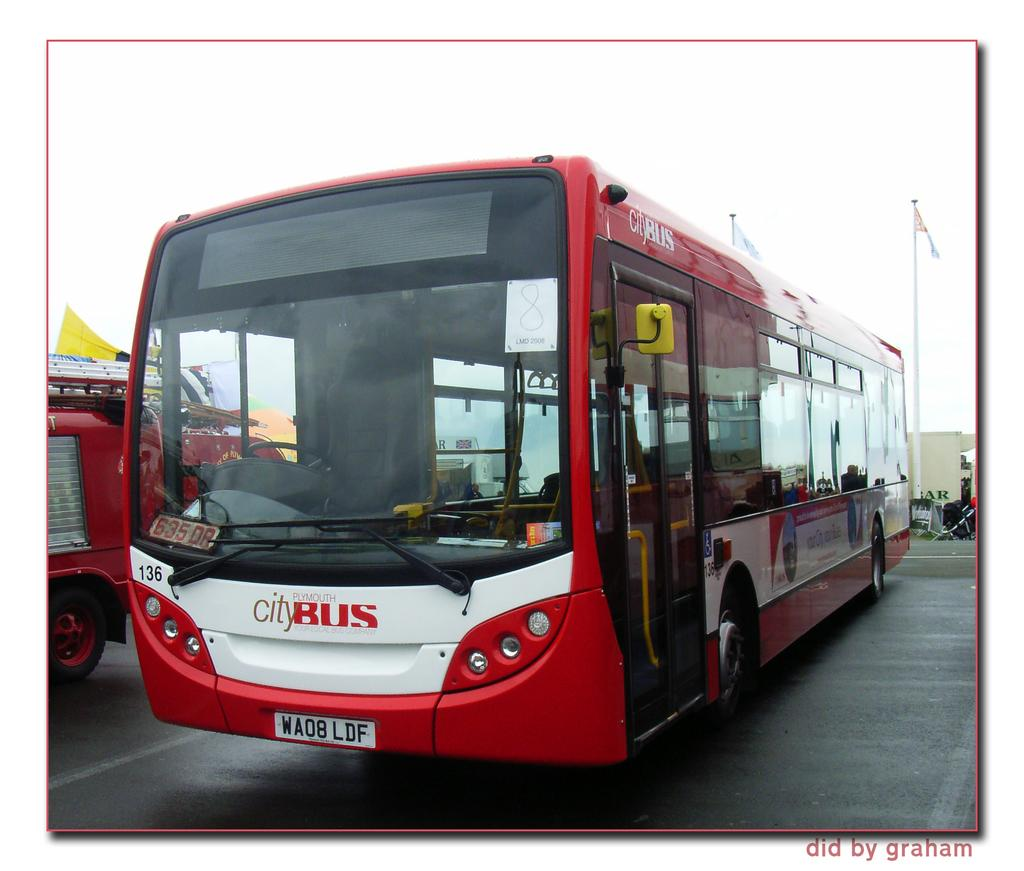Provide a one-sentence caption for the provided image. A red Plymouth city bus is parked in a lot. 